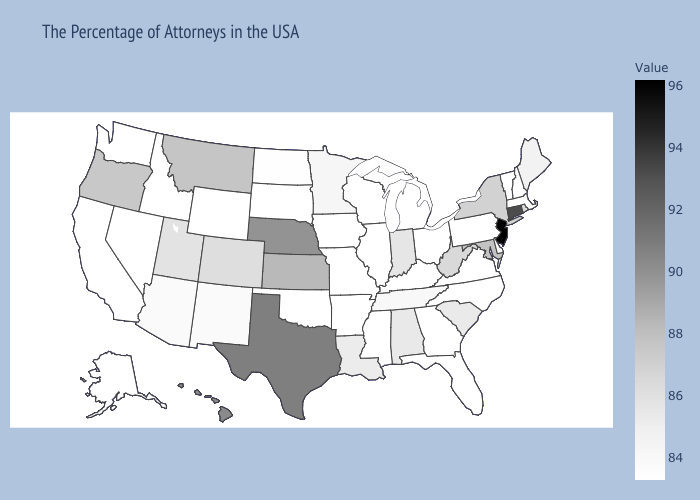Among the states that border Maryland , which have the lowest value?
Answer briefly. Pennsylvania, Virginia. Does Alabama have a higher value than Kansas?
Concise answer only. No. Does Massachusetts have the lowest value in the Northeast?
Concise answer only. Yes. Does the map have missing data?
Quick response, please. No. Which states hav the highest value in the MidWest?
Be succinct. Nebraska. Which states have the lowest value in the USA?
Quick response, please. Massachusetts, New Hampshire, Vermont, Pennsylvania, Virginia, North Carolina, Ohio, Florida, Georgia, Michigan, Kentucky, Wisconsin, Illinois, Mississippi, Missouri, Arkansas, Iowa, Oklahoma, South Dakota, Wyoming, Idaho, Nevada, California, Washington, Alaska. 